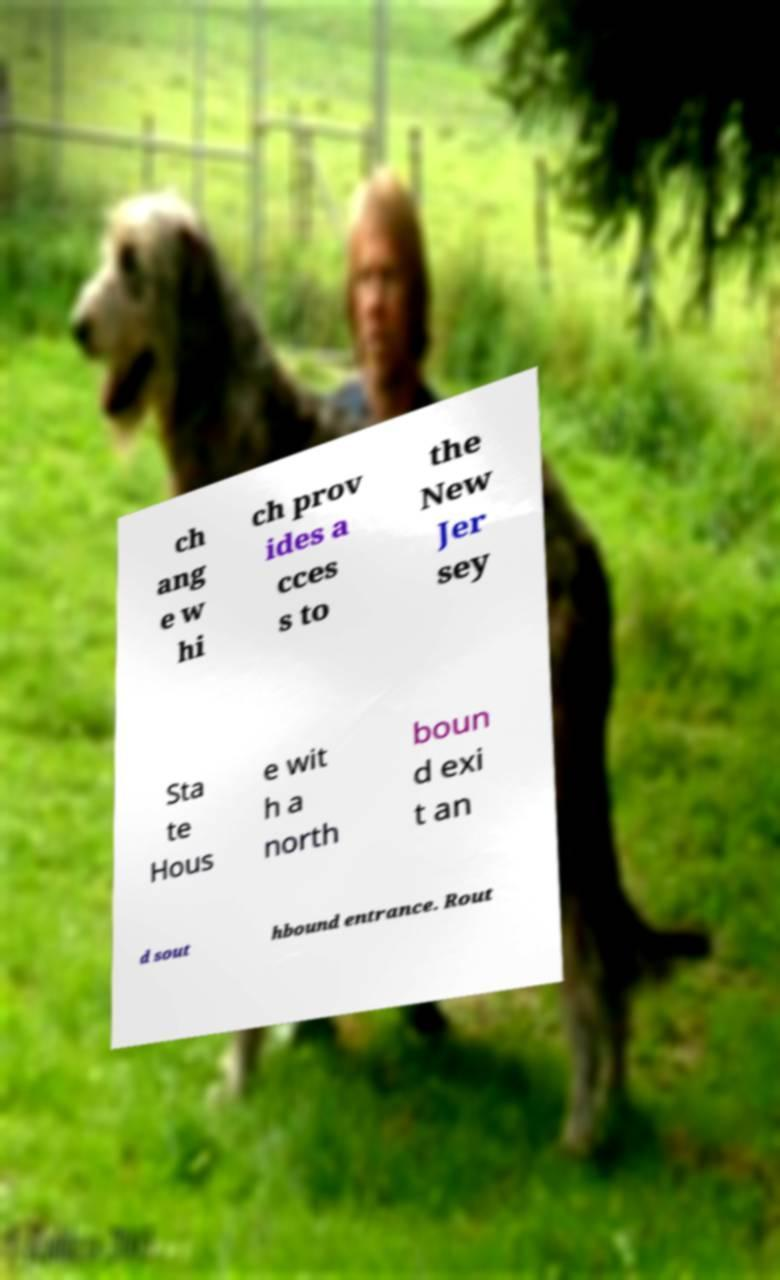Can you accurately transcribe the text from the provided image for me? ch ang e w hi ch prov ides a cces s to the New Jer sey Sta te Hous e wit h a north boun d exi t an d sout hbound entrance. Rout 